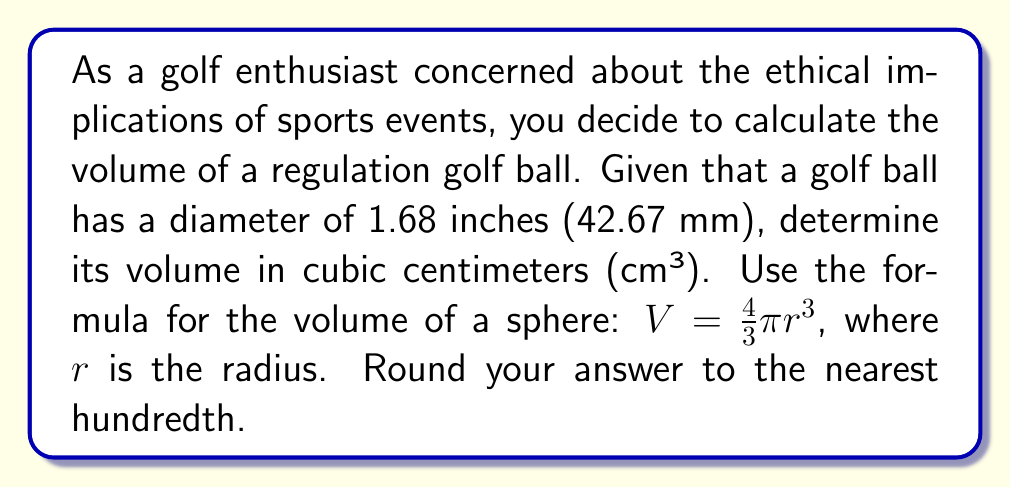Provide a solution to this math problem. Let's approach this step-by-step:

1. First, we need to convert the diameter from inches to centimeters:
   $1.68 \text{ inches} \times 2.54 \text{ cm/inch} = 4.2672 \text{ cm}$

2. Now we have the diameter in centimeters. To find the radius, we divide by 2:
   $r = \frac{4.2672}{2} = 2.1336 \text{ cm}$

3. Let's substitute this into the volume formula:
   $V = \frac{4}{3}\pi r^3$
   $V = \frac{4}{3}\pi (2.1336)^3$

4. Calculating:
   $V = \frac{4}{3} \times \pi \times 9.7090295296$
   $V = 4.1887902461 \times 9.7090295296$
   $V = 40.6725261463 \text{ cm}^3$

5. Rounding to the nearest hundredth:
   $V \approx 40.67 \text{ cm}^3$

[asy]
import geometry;

size(100);
draw(circle((0,0),1), rgb(0,0.7,0));
draw((0,0)--(1,0), Arrow);
label("$r$", (0.5,0.1), N);
label("Golf Ball", (0,-1.3), S);
[/asy]
Answer: $40.67 \text{ cm}^3$ 